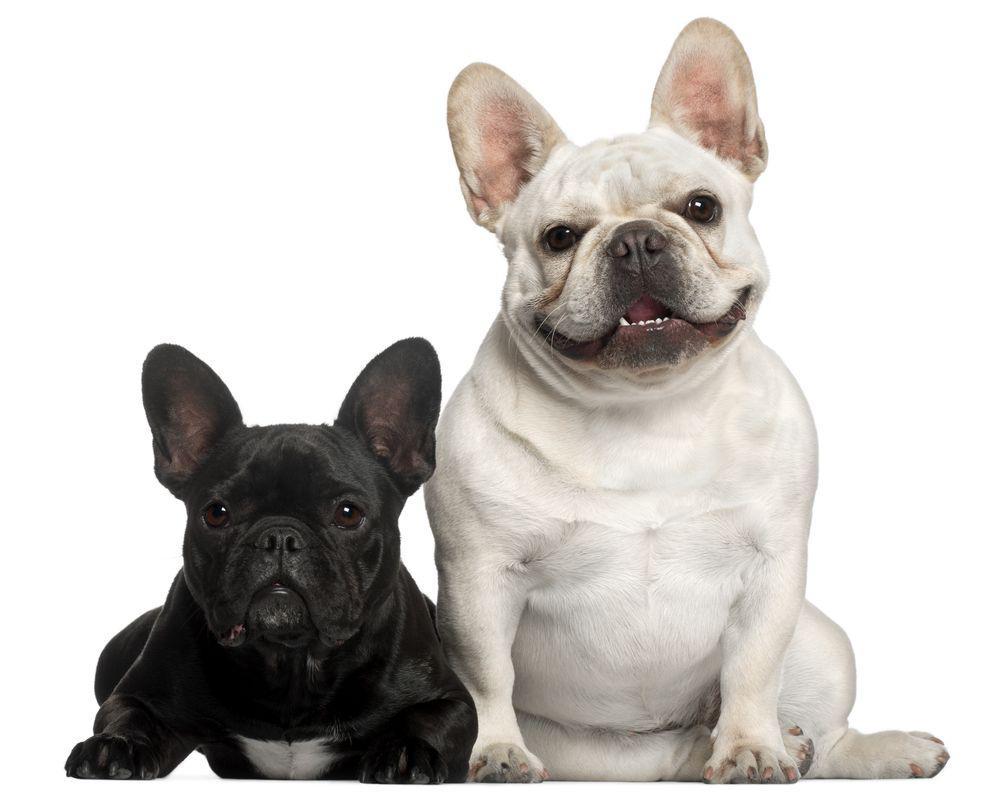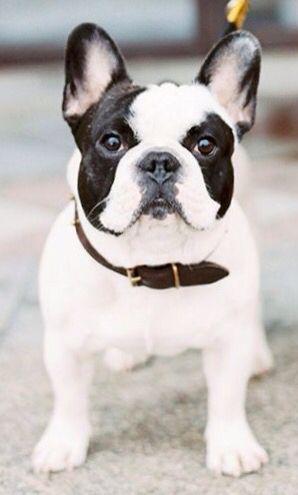The first image is the image on the left, the second image is the image on the right. Evaluate the accuracy of this statement regarding the images: "One image shows a french bulldog standing on all fours, and the other image includes a white bulldog looking straight at the camera.". Is it true? Answer yes or no. Yes. The first image is the image on the left, the second image is the image on the right. Assess this claim about the two images: "One dog is standing.". Correct or not? Answer yes or no. Yes. 